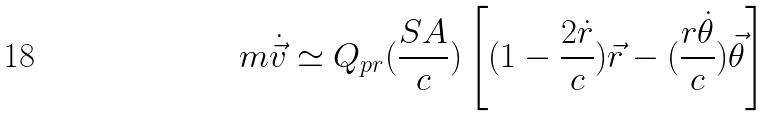<formula> <loc_0><loc_0><loc_500><loc_500>m \dot { \vec { v } } \simeq Q _ { p r } ( \frac { S A } { c } ) \left [ ( 1 - \frac { 2 \dot { r } } { c } ) \vec { r } - ( \frac { r \dot { \theta } } { c } ) \vec { \theta } \right ]</formula> 